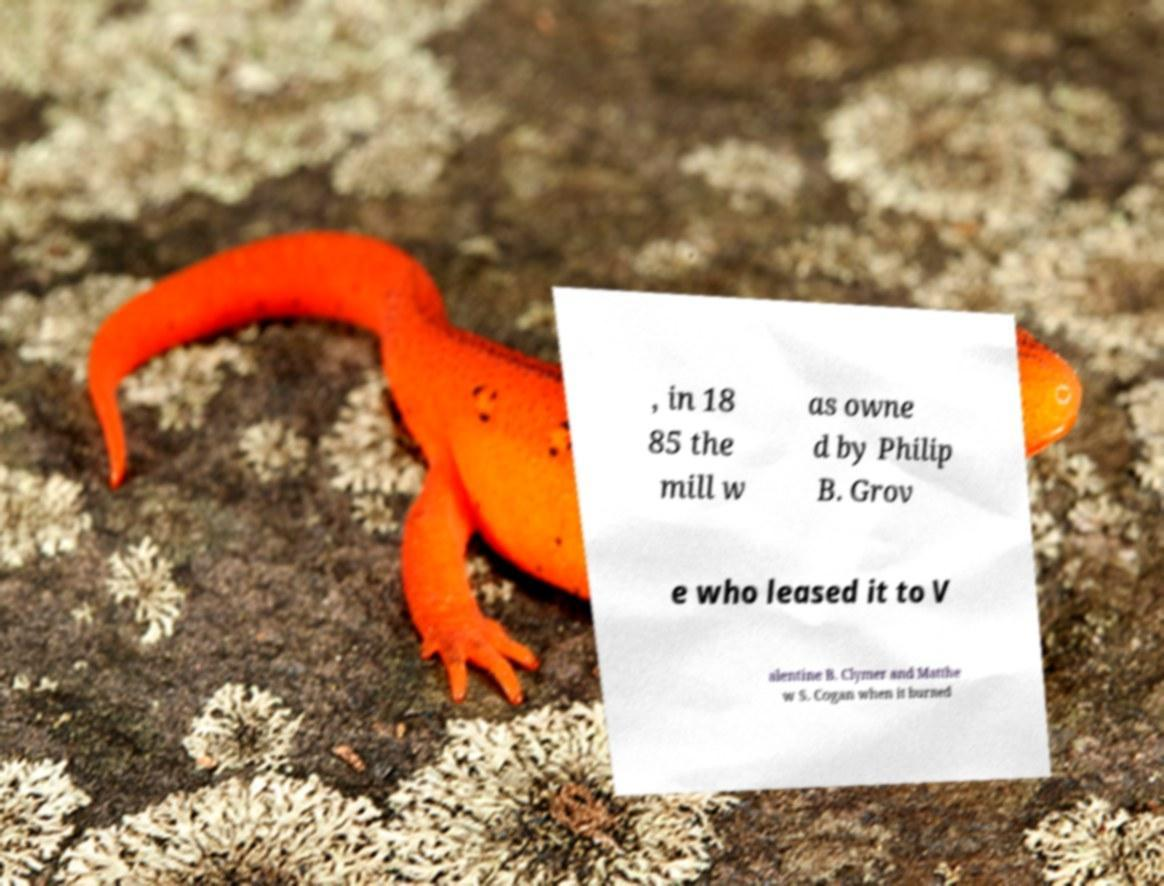Can you accurately transcribe the text from the provided image for me? , in 18 85 the mill w as owne d by Philip B. Grov e who leased it to V alentine B. Clymer and Matthe w S. Cogan when it burned 